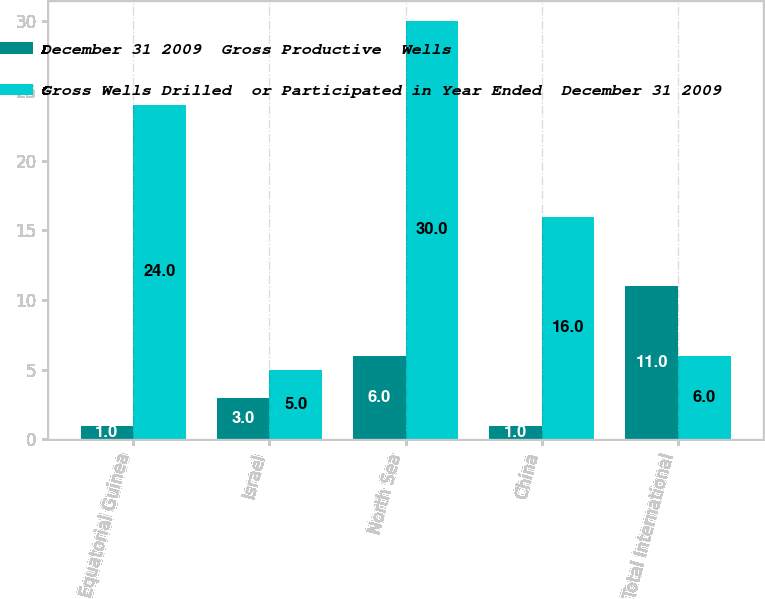<chart> <loc_0><loc_0><loc_500><loc_500><stacked_bar_chart><ecel><fcel>Equatorial Guinea<fcel>Israel<fcel>North Sea<fcel>China<fcel>Total International<nl><fcel>December 31 2009  Gross Productive  Wells<fcel>1<fcel>3<fcel>6<fcel>1<fcel>11<nl><fcel>Gross Wells Drilled  or Participated in Year Ended  December 31 2009<fcel>24<fcel>5<fcel>30<fcel>16<fcel>6<nl></chart> 